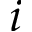<formula> <loc_0><loc_0><loc_500><loc_500>i</formula> 